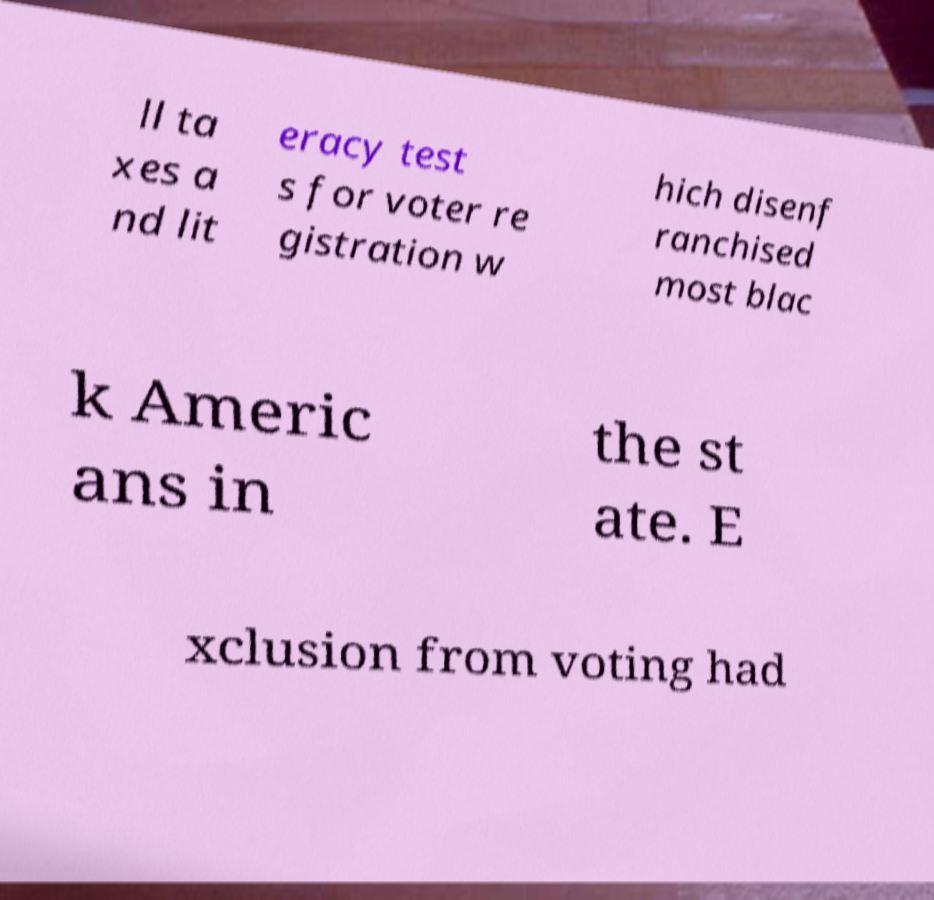Please identify and transcribe the text found in this image. ll ta xes a nd lit eracy test s for voter re gistration w hich disenf ranchised most blac k Americ ans in the st ate. E xclusion from voting had 